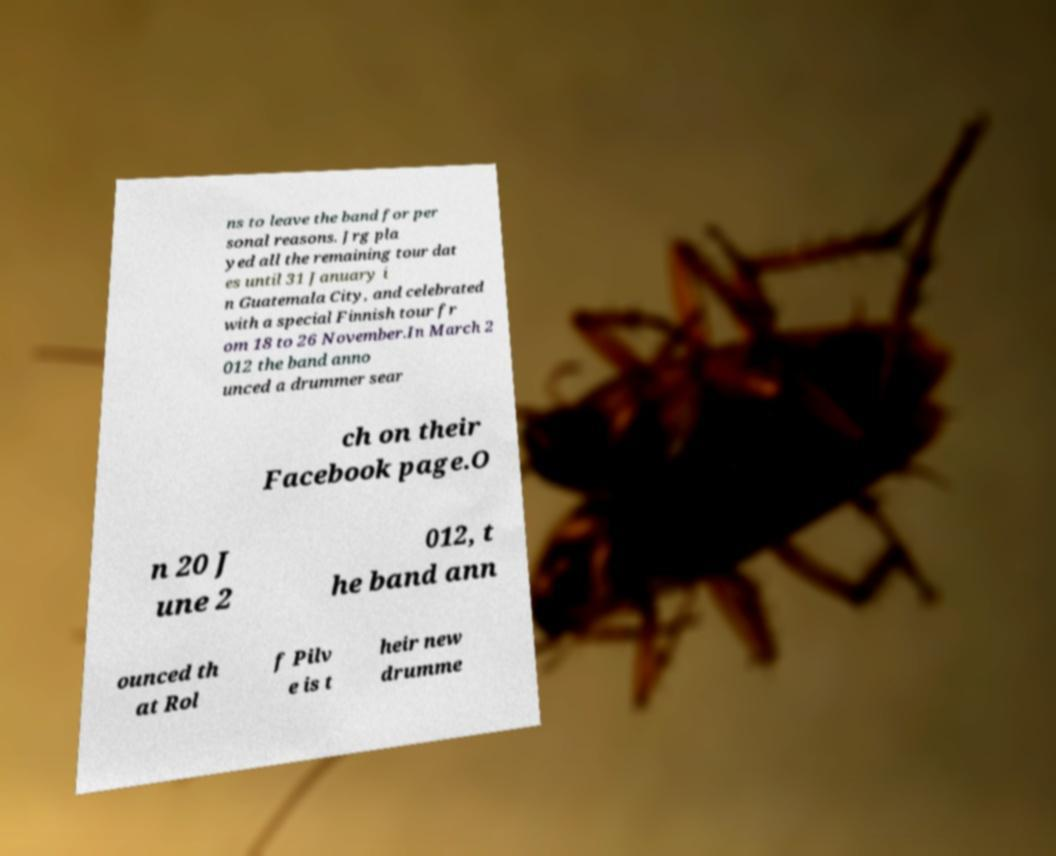What messages or text are displayed in this image? I need them in a readable, typed format. ns to leave the band for per sonal reasons. Jrg pla yed all the remaining tour dat es until 31 January i n Guatemala City, and celebrated with a special Finnish tour fr om 18 to 26 November.In March 2 012 the band anno unced a drummer sear ch on their Facebook page.O n 20 J une 2 012, t he band ann ounced th at Rol f Pilv e is t heir new drumme 